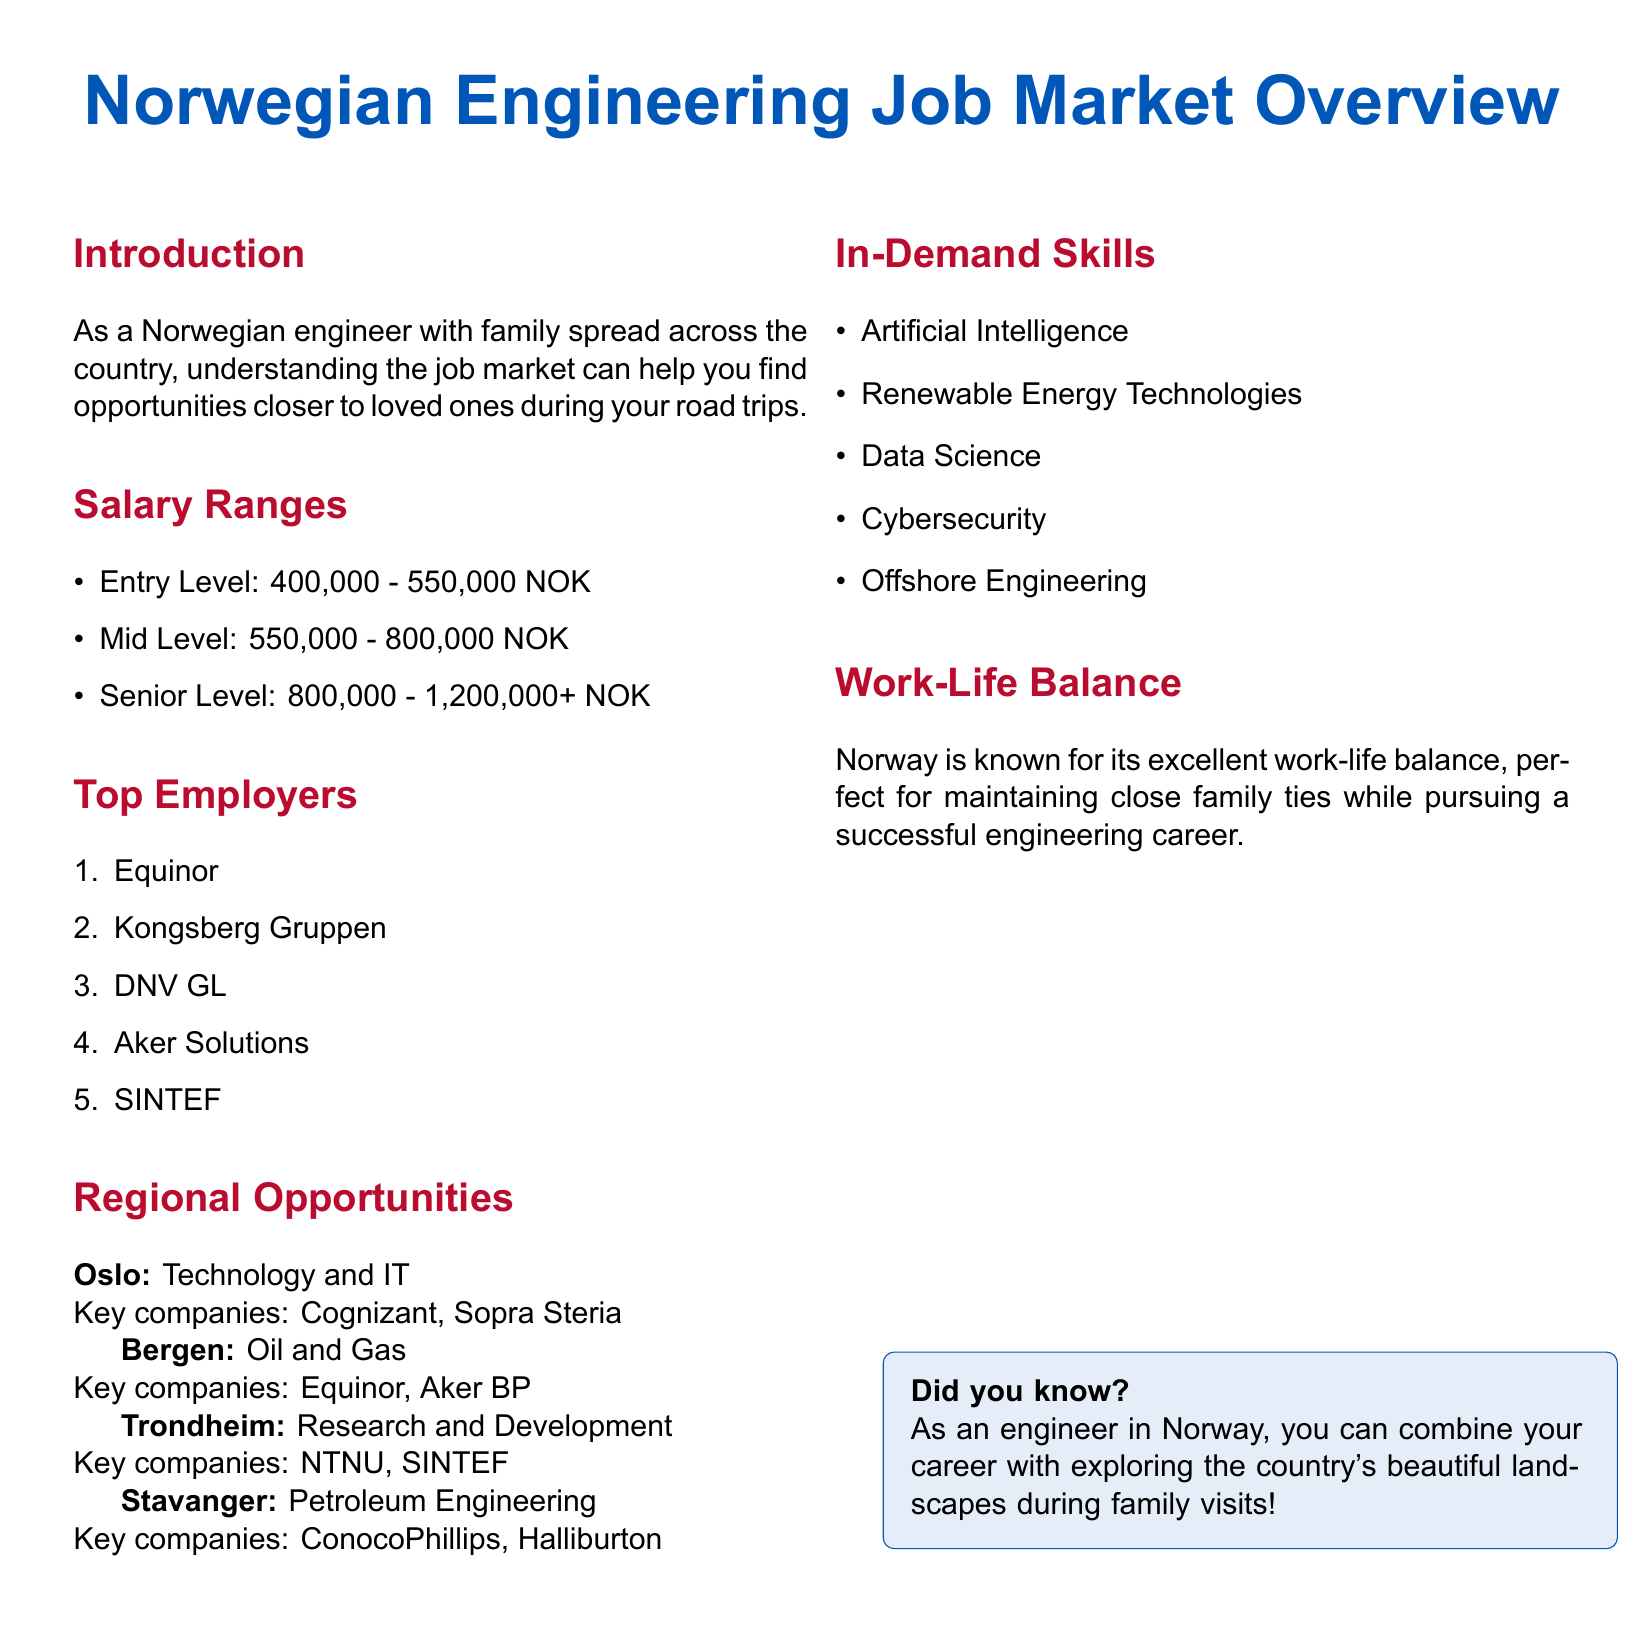What is the salary range for entry-level engineering positions? The salary range for entry-level positions is specified in the document under salary ranges.
Answer: 400,000 - 550,000 NOK Which company is listed as a top employer in Norway? The document provides a list of top employers in Norway, mentioning several by name.
Answer: Equinor What region is associated with oil and gas opportunities? The document specifies regions and their associated opportunities, indicating which field is prominent in each area.
Answer: Bergen What is the top in-demand skill listed in the document? The in-demand skills are enumerated in the document, highlighting the most sought-after skills in the job market.
Answer: Artificial Intelligence Which city is mentioned for Technology and IT job opportunities? The document lists regional opportunities and specifies key fields for each city which helps find potential job locations.
Answer: Oslo What is the upper salary limit for senior-level positions? The document outlines salary ranges for various experience levels, focusing especially on senior-level positions.
Answer: 1,200,000+ NOK How does the document describe Norway's work-life balance? The document has a section dedicated to work-life balance, discussing its relevance to engineers.
Answer: Excellent Which company in Stavanger is key for petroleum engineering? The document identifies specific key companies associated with each region and field of engineering.
Answer: ConocoPhillips 